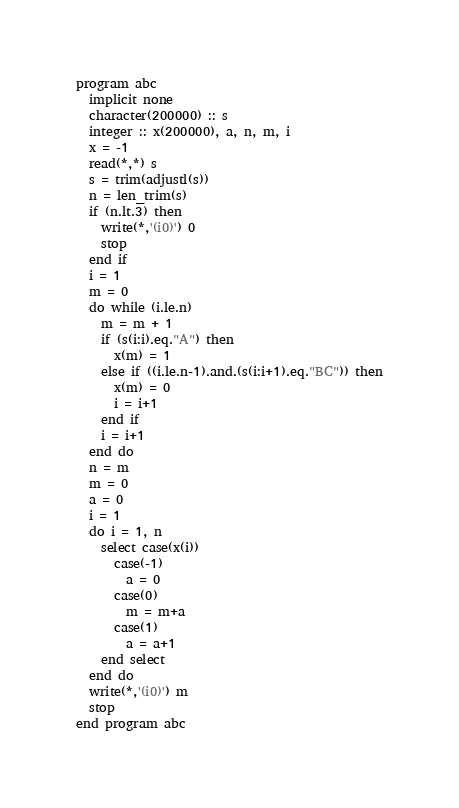<code> <loc_0><loc_0><loc_500><loc_500><_FORTRAN_>program abc
  implicit none
  character(200000) :: s
  integer :: x(200000), a, n, m, i
  x = -1
  read(*,*) s
  s = trim(adjustl(s))
  n = len_trim(s)
  if (n.lt.3) then
    write(*,'(i0)') 0
    stop
  end if
  i = 1
  m = 0
  do while (i.le.n)
    m = m + 1
    if (s(i:i).eq."A") then
      x(m) = 1
    else if ((i.le.n-1).and.(s(i:i+1).eq."BC")) then
      x(m) = 0
      i = i+1
    end if
    i = i+1
  end do
  n = m
  m = 0
  a = 0
  i = 1
  do i = 1, n
    select case(x(i))
      case(-1)
        a = 0
      case(0)
        m = m+a
      case(1)
        a = a+1
    end select
  end do
  write(*,'(i0)') m
  stop
end program abc</code> 